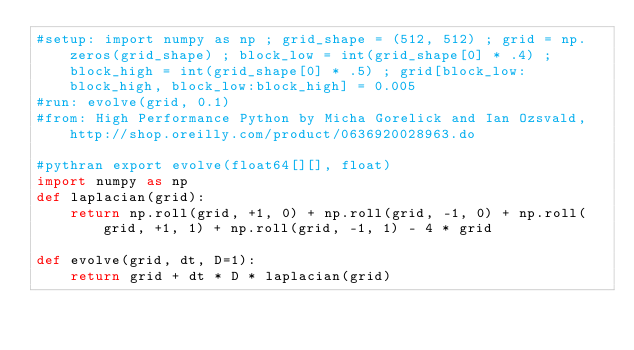<code> <loc_0><loc_0><loc_500><loc_500><_Python_>#setup: import numpy as np ; grid_shape = (512, 512) ; grid = np.zeros(grid_shape) ; block_low = int(grid_shape[0] * .4) ; block_high = int(grid_shape[0] * .5) ; grid[block_low:block_high, block_low:block_high] = 0.005
#run: evolve(grid, 0.1)
#from: High Performance Python by Micha Gorelick and Ian Ozsvald, http://shop.oreilly.com/product/0636920028963.do

#pythran export evolve(float64[][], float)
import numpy as np
def laplacian(grid):
    return np.roll(grid, +1, 0) + np.roll(grid, -1, 0) + np.roll(grid, +1, 1) + np.roll(grid, -1, 1) - 4 * grid

def evolve(grid, dt, D=1):
    return grid + dt * D * laplacian(grid)
</code> 